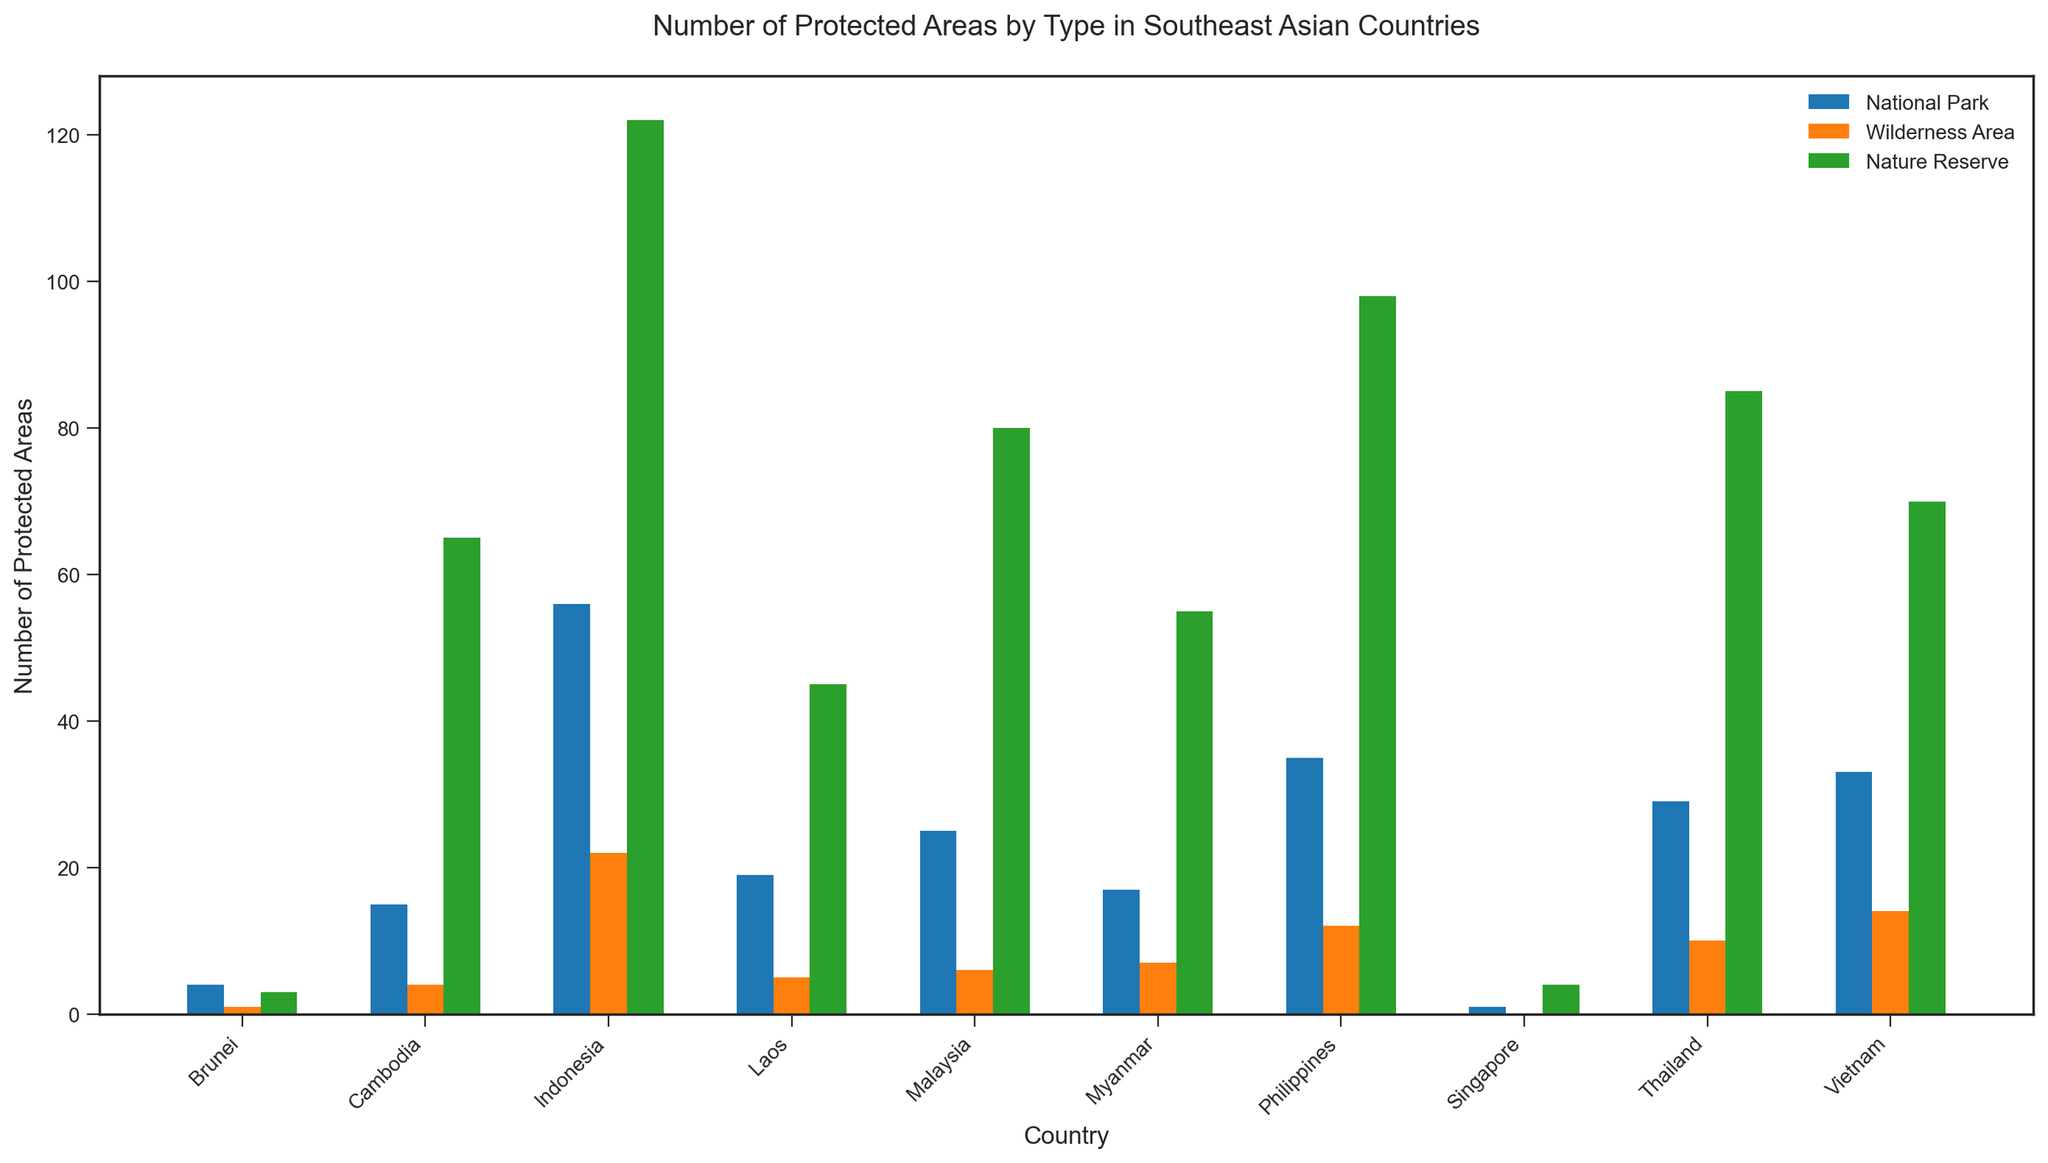What is the country with the highest number of Nature Reserves? Look for the highest bar in the Nature Reserve (colored green) category; Indonesia has the highest bar in this category
Answer: Indonesia Which country has the least number of Wilderness Areas? Look for the shortest bar in the Wilderness Area (colored orange) category; Singapore has the shortest bar, with a count of 0
Answer: Singapore How many National Parks are there in total across all countries? Sum the heights of all the National Park (colored blue) bars: 56 (Indonesia) + 25 (Malaysia) + 35 (Philippines) + 29 (Thailand) + 33 (Vietnam) + 17 (Myanmar) + 15 (Cambodia) + 19 (Laos) + 4 (Brunei) + 1 (Singapore) = 234
Answer: 234 Which country has a higher number of National Parks, Philippines or Vietnam? Compare the heights of the National Park bars (colored blue) for both countries: Philippines has 35, and Vietnam has 33
Answer: Philippines What is the total number of protected areas in Thailand? Sum the heights of all types of protected areas for Thailand: 29 (National Park) + 10 (Wilderness Area) + 85 (Nature Reserve) = 124
Answer: 124 Which type of protected area is most common in Malaysia? Compare the heights of different types of bars for Malaysia; the Nature Reserve bar (colored green) is the highest with 80
Answer: Nature Reserve How many more Nature Reserves does the Philippines have compared to Myanmar? Subtract the number of Nature Reserves in Myanmar from the number in the Philippines: 98 (Philippines) - 55 (Myanmar) = 43
Answer: 43 In which countries is there at least one Wilderness Area, but not more than 10? Look for the orange bars representing Wilderness Areas that are between 1 and 10: Malaysia (6), Thailand (10), Myanmar (7), Cambodia (4), and Laos (5)
Answer: Malaysia, Thailand, Myanmar, Cambodia, Laos What is the average number of National Parks across the countries? Sum all National Parks and divide by the number of countries: (56+25+35+29+33+17+15+19+4+1)/10 = 23.4
Answer: 23.4 How does the number of Nature Reserves in Cambodia compare to those in Vietnam? Compare the heights of the bars representing Nature Reserves (colored green) for both countries: Cambodia has 65, and Vietnam has 70
Answer: Vietnam has more 